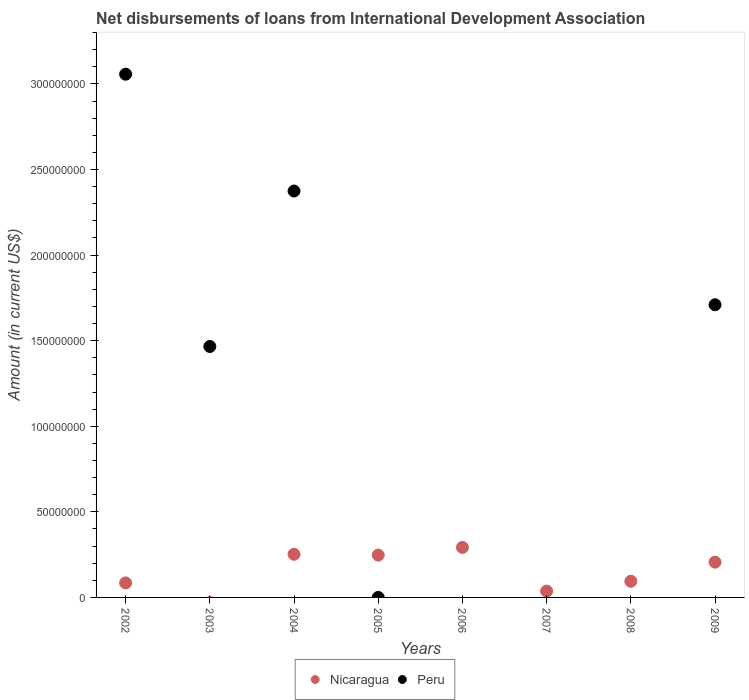What is the amount of loans disbursed in Peru in 2004?
Offer a very short reply. 2.37e+08. Across all years, what is the maximum amount of loans disbursed in Nicaragua?
Offer a terse response. 2.92e+07. Across all years, what is the minimum amount of loans disbursed in Peru?
Your response must be concise. 0. In which year was the amount of loans disbursed in Peru maximum?
Provide a short and direct response. 2002. What is the total amount of loans disbursed in Peru in the graph?
Provide a short and direct response. 8.61e+08. What is the difference between the amount of loans disbursed in Nicaragua in 2005 and that in 2008?
Provide a short and direct response. 1.53e+07. What is the difference between the amount of loans disbursed in Nicaragua in 2005 and the amount of loans disbursed in Peru in 2007?
Provide a short and direct response. 2.47e+07. What is the average amount of loans disbursed in Peru per year?
Your answer should be very brief. 1.08e+08. In the year 2002, what is the difference between the amount of loans disbursed in Nicaragua and amount of loans disbursed in Peru?
Provide a short and direct response. -2.97e+08. In how many years, is the amount of loans disbursed in Nicaragua greater than 300000000 US$?
Keep it short and to the point. 0. What is the ratio of the amount of loans disbursed in Nicaragua in 2002 to that in 2004?
Your answer should be very brief. 0.34. Is the amount of loans disbursed in Nicaragua in 2002 less than that in 2006?
Provide a succinct answer. Yes. What is the difference between the highest and the second highest amount of loans disbursed in Peru?
Offer a very short reply. 6.82e+07. What is the difference between the highest and the lowest amount of loans disbursed in Peru?
Give a very brief answer. 3.06e+08. In how many years, is the amount of loans disbursed in Nicaragua greater than the average amount of loans disbursed in Nicaragua taken over all years?
Your answer should be very brief. 4. Is the amount of loans disbursed in Peru strictly less than the amount of loans disbursed in Nicaragua over the years?
Offer a very short reply. No. How many dotlines are there?
Your answer should be very brief. 2. What is the difference between two consecutive major ticks on the Y-axis?
Offer a terse response. 5.00e+07. Are the values on the major ticks of Y-axis written in scientific E-notation?
Offer a terse response. No. Does the graph contain any zero values?
Offer a very short reply. Yes. Does the graph contain grids?
Provide a short and direct response. No. What is the title of the graph?
Your response must be concise. Net disbursements of loans from International Development Association. What is the label or title of the X-axis?
Keep it short and to the point. Years. What is the label or title of the Y-axis?
Your answer should be very brief. Amount (in current US$). What is the Amount (in current US$) of Nicaragua in 2002?
Offer a very short reply. 8.49e+06. What is the Amount (in current US$) in Peru in 2002?
Keep it short and to the point. 3.06e+08. What is the Amount (in current US$) of Nicaragua in 2003?
Give a very brief answer. 0. What is the Amount (in current US$) of Peru in 2003?
Offer a very short reply. 1.47e+08. What is the Amount (in current US$) of Nicaragua in 2004?
Keep it short and to the point. 2.52e+07. What is the Amount (in current US$) in Peru in 2004?
Provide a short and direct response. 2.37e+08. What is the Amount (in current US$) of Nicaragua in 2005?
Keep it short and to the point. 2.47e+07. What is the Amount (in current US$) of Peru in 2005?
Make the answer very short. 0. What is the Amount (in current US$) of Nicaragua in 2006?
Ensure brevity in your answer.  2.92e+07. What is the Amount (in current US$) in Peru in 2006?
Your answer should be very brief. 0. What is the Amount (in current US$) in Nicaragua in 2007?
Provide a short and direct response. 3.68e+06. What is the Amount (in current US$) of Peru in 2007?
Make the answer very short. 0. What is the Amount (in current US$) of Nicaragua in 2008?
Provide a succinct answer. 9.45e+06. What is the Amount (in current US$) of Peru in 2008?
Provide a succinct answer. 0. What is the Amount (in current US$) in Nicaragua in 2009?
Make the answer very short. 2.06e+07. What is the Amount (in current US$) in Peru in 2009?
Provide a succinct answer. 1.71e+08. Across all years, what is the maximum Amount (in current US$) in Nicaragua?
Give a very brief answer. 2.92e+07. Across all years, what is the maximum Amount (in current US$) of Peru?
Give a very brief answer. 3.06e+08. What is the total Amount (in current US$) in Nicaragua in the graph?
Provide a short and direct response. 1.21e+08. What is the total Amount (in current US$) of Peru in the graph?
Keep it short and to the point. 8.61e+08. What is the difference between the Amount (in current US$) in Peru in 2002 and that in 2003?
Make the answer very short. 1.59e+08. What is the difference between the Amount (in current US$) in Nicaragua in 2002 and that in 2004?
Your response must be concise. -1.67e+07. What is the difference between the Amount (in current US$) in Peru in 2002 and that in 2004?
Provide a short and direct response. 6.82e+07. What is the difference between the Amount (in current US$) in Nicaragua in 2002 and that in 2005?
Keep it short and to the point. -1.62e+07. What is the difference between the Amount (in current US$) of Nicaragua in 2002 and that in 2006?
Provide a short and direct response. -2.07e+07. What is the difference between the Amount (in current US$) in Nicaragua in 2002 and that in 2007?
Offer a very short reply. 4.81e+06. What is the difference between the Amount (in current US$) of Nicaragua in 2002 and that in 2008?
Your answer should be compact. -9.56e+05. What is the difference between the Amount (in current US$) in Nicaragua in 2002 and that in 2009?
Your response must be concise. -1.21e+07. What is the difference between the Amount (in current US$) of Peru in 2002 and that in 2009?
Your response must be concise. 1.35e+08. What is the difference between the Amount (in current US$) in Peru in 2003 and that in 2004?
Provide a succinct answer. -9.08e+07. What is the difference between the Amount (in current US$) of Peru in 2003 and that in 2009?
Provide a short and direct response. -2.44e+07. What is the difference between the Amount (in current US$) of Nicaragua in 2004 and that in 2005?
Your response must be concise. 4.97e+05. What is the difference between the Amount (in current US$) of Nicaragua in 2004 and that in 2006?
Your answer should be very brief. -4.02e+06. What is the difference between the Amount (in current US$) of Nicaragua in 2004 and that in 2007?
Provide a short and direct response. 2.15e+07. What is the difference between the Amount (in current US$) of Nicaragua in 2004 and that in 2008?
Provide a succinct answer. 1.58e+07. What is the difference between the Amount (in current US$) in Nicaragua in 2004 and that in 2009?
Make the answer very short. 4.61e+06. What is the difference between the Amount (in current US$) in Peru in 2004 and that in 2009?
Give a very brief answer. 6.64e+07. What is the difference between the Amount (in current US$) in Nicaragua in 2005 and that in 2006?
Provide a succinct answer. -4.52e+06. What is the difference between the Amount (in current US$) in Nicaragua in 2005 and that in 2007?
Keep it short and to the point. 2.10e+07. What is the difference between the Amount (in current US$) in Nicaragua in 2005 and that in 2008?
Keep it short and to the point. 1.53e+07. What is the difference between the Amount (in current US$) in Nicaragua in 2005 and that in 2009?
Make the answer very short. 4.11e+06. What is the difference between the Amount (in current US$) in Nicaragua in 2006 and that in 2007?
Ensure brevity in your answer.  2.56e+07. What is the difference between the Amount (in current US$) of Nicaragua in 2006 and that in 2008?
Keep it short and to the point. 1.98e+07. What is the difference between the Amount (in current US$) of Nicaragua in 2006 and that in 2009?
Keep it short and to the point. 8.63e+06. What is the difference between the Amount (in current US$) in Nicaragua in 2007 and that in 2008?
Ensure brevity in your answer.  -5.77e+06. What is the difference between the Amount (in current US$) in Nicaragua in 2007 and that in 2009?
Offer a very short reply. -1.69e+07. What is the difference between the Amount (in current US$) in Nicaragua in 2008 and that in 2009?
Your answer should be compact. -1.12e+07. What is the difference between the Amount (in current US$) of Nicaragua in 2002 and the Amount (in current US$) of Peru in 2003?
Provide a succinct answer. -1.38e+08. What is the difference between the Amount (in current US$) in Nicaragua in 2002 and the Amount (in current US$) in Peru in 2004?
Your response must be concise. -2.29e+08. What is the difference between the Amount (in current US$) in Nicaragua in 2002 and the Amount (in current US$) in Peru in 2009?
Keep it short and to the point. -1.62e+08. What is the difference between the Amount (in current US$) of Nicaragua in 2004 and the Amount (in current US$) of Peru in 2009?
Provide a short and direct response. -1.46e+08. What is the difference between the Amount (in current US$) in Nicaragua in 2005 and the Amount (in current US$) in Peru in 2009?
Your response must be concise. -1.46e+08. What is the difference between the Amount (in current US$) of Nicaragua in 2006 and the Amount (in current US$) of Peru in 2009?
Give a very brief answer. -1.42e+08. What is the difference between the Amount (in current US$) of Nicaragua in 2007 and the Amount (in current US$) of Peru in 2009?
Ensure brevity in your answer.  -1.67e+08. What is the difference between the Amount (in current US$) in Nicaragua in 2008 and the Amount (in current US$) in Peru in 2009?
Offer a terse response. -1.62e+08. What is the average Amount (in current US$) of Nicaragua per year?
Your answer should be compact. 1.52e+07. What is the average Amount (in current US$) in Peru per year?
Your response must be concise. 1.08e+08. In the year 2002, what is the difference between the Amount (in current US$) of Nicaragua and Amount (in current US$) of Peru?
Your answer should be very brief. -2.97e+08. In the year 2004, what is the difference between the Amount (in current US$) of Nicaragua and Amount (in current US$) of Peru?
Offer a terse response. -2.12e+08. In the year 2009, what is the difference between the Amount (in current US$) of Nicaragua and Amount (in current US$) of Peru?
Provide a short and direct response. -1.50e+08. What is the ratio of the Amount (in current US$) of Peru in 2002 to that in 2003?
Give a very brief answer. 2.08. What is the ratio of the Amount (in current US$) in Nicaragua in 2002 to that in 2004?
Make the answer very short. 0.34. What is the ratio of the Amount (in current US$) in Peru in 2002 to that in 2004?
Ensure brevity in your answer.  1.29. What is the ratio of the Amount (in current US$) in Nicaragua in 2002 to that in 2005?
Make the answer very short. 0.34. What is the ratio of the Amount (in current US$) of Nicaragua in 2002 to that in 2006?
Your answer should be very brief. 0.29. What is the ratio of the Amount (in current US$) in Nicaragua in 2002 to that in 2007?
Keep it short and to the point. 2.31. What is the ratio of the Amount (in current US$) of Nicaragua in 2002 to that in 2008?
Provide a short and direct response. 0.9. What is the ratio of the Amount (in current US$) in Nicaragua in 2002 to that in 2009?
Offer a very short reply. 0.41. What is the ratio of the Amount (in current US$) of Peru in 2002 to that in 2009?
Provide a succinct answer. 1.79. What is the ratio of the Amount (in current US$) of Peru in 2003 to that in 2004?
Your answer should be very brief. 0.62. What is the ratio of the Amount (in current US$) of Peru in 2003 to that in 2009?
Provide a succinct answer. 0.86. What is the ratio of the Amount (in current US$) of Nicaragua in 2004 to that in 2005?
Your answer should be compact. 1.02. What is the ratio of the Amount (in current US$) of Nicaragua in 2004 to that in 2006?
Offer a very short reply. 0.86. What is the ratio of the Amount (in current US$) of Nicaragua in 2004 to that in 2007?
Give a very brief answer. 6.85. What is the ratio of the Amount (in current US$) in Nicaragua in 2004 to that in 2008?
Make the answer very short. 2.67. What is the ratio of the Amount (in current US$) of Nicaragua in 2004 to that in 2009?
Ensure brevity in your answer.  1.22. What is the ratio of the Amount (in current US$) of Peru in 2004 to that in 2009?
Your response must be concise. 1.39. What is the ratio of the Amount (in current US$) of Nicaragua in 2005 to that in 2006?
Offer a terse response. 0.85. What is the ratio of the Amount (in current US$) in Nicaragua in 2005 to that in 2007?
Your response must be concise. 6.71. What is the ratio of the Amount (in current US$) in Nicaragua in 2005 to that in 2008?
Make the answer very short. 2.62. What is the ratio of the Amount (in current US$) in Nicaragua in 2005 to that in 2009?
Give a very brief answer. 1.2. What is the ratio of the Amount (in current US$) of Nicaragua in 2006 to that in 2007?
Your answer should be very brief. 7.94. What is the ratio of the Amount (in current US$) of Nicaragua in 2006 to that in 2008?
Keep it short and to the point. 3.09. What is the ratio of the Amount (in current US$) of Nicaragua in 2006 to that in 2009?
Your response must be concise. 1.42. What is the ratio of the Amount (in current US$) of Nicaragua in 2007 to that in 2008?
Keep it short and to the point. 0.39. What is the ratio of the Amount (in current US$) in Nicaragua in 2007 to that in 2009?
Your answer should be very brief. 0.18. What is the ratio of the Amount (in current US$) in Nicaragua in 2008 to that in 2009?
Make the answer very short. 0.46. What is the difference between the highest and the second highest Amount (in current US$) in Nicaragua?
Your answer should be very brief. 4.02e+06. What is the difference between the highest and the second highest Amount (in current US$) of Peru?
Provide a succinct answer. 6.82e+07. What is the difference between the highest and the lowest Amount (in current US$) in Nicaragua?
Ensure brevity in your answer.  2.92e+07. What is the difference between the highest and the lowest Amount (in current US$) in Peru?
Ensure brevity in your answer.  3.06e+08. 